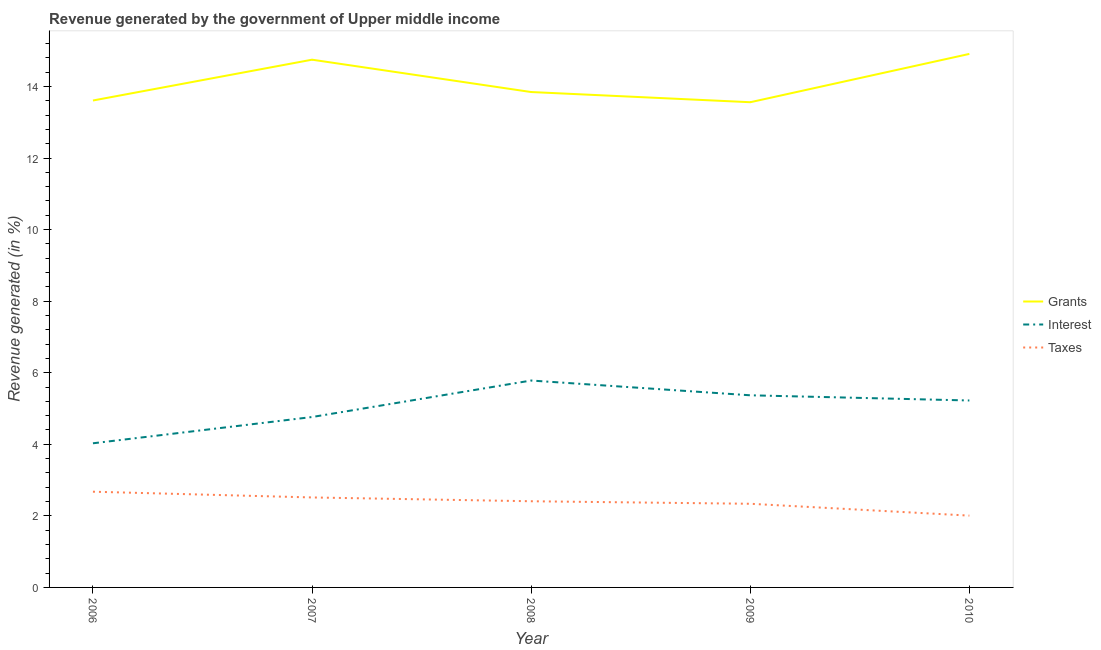Does the line corresponding to percentage of revenue generated by taxes intersect with the line corresponding to percentage of revenue generated by interest?
Provide a succinct answer. No. Is the number of lines equal to the number of legend labels?
Ensure brevity in your answer.  Yes. What is the percentage of revenue generated by taxes in 2010?
Give a very brief answer. 2.01. Across all years, what is the maximum percentage of revenue generated by taxes?
Give a very brief answer. 2.68. Across all years, what is the minimum percentage of revenue generated by interest?
Your answer should be compact. 4.03. In which year was the percentage of revenue generated by grants maximum?
Provide a succinct answer. 2010. In which year was the percentage of revenue generated by interest minimum?
Your response must be concise. 2006. What is the total percentage of revenue generated by taxes in the graph?
Your answer should be very brief. 11.94. What is the difference between the percentage of revenue generated by grants in 2006 and that in 2010?
Your answer should be compact. -1.3. What is the difference between the percentage of revenue generated by taxes in 2008 and the percentage of revenue generated by interest in 2006?
Keep it short and to the point. -1.62. What is the average percentage of revenue generated by grants per year?
Provide a short and direct response. 14.13. In the year 2007, what is the difference between the percentage of revenue generated by interest and percentage of revenue generated by taxes?
Make the answer very short. 2.25. In how many years, is the percentage of revenue generated by taxes greater than 14.4 %?
Keep it short and to the point. 0. What is the ratio of the percentage of revenue generated by grants in 2007 to that in 2009?
Your answer should be very brief. 1.09. Is the difference between the percentage of revenue generated by interest in 2006 and 2008 greater than the difference between the percentage of revenue generated by taxes in 2006 and 2008?
Keep it short and to the point. No. What is the difference between the highest and the second highest percentage of revenue generated by grants?
Make the answer very short. 0.16. What is the difference between the highest and the lowest percentage of revenue generated by interest?
Keep it short and to the point. 1.75. In how many years, is the percentage of revenue generated by interest greater than the average percentage of revenue generated by interest taken over all years?
Your response must be concise. 3. Is the sum of the percentage of revenue generated by taxes in 2006 and 2009 greater than the maximum percentage of revenue generated by interest across all years?
Provide a succinct answer. No. Is it the case that in every year, the sum of the percentage of revenue generated by grants and percentage of revenue generated by interest is greater than the percentage of revenue generated by taxes?
Ensure brevity in your answer.  Yes. Does the percentage of revenue generated by grants monotonically increase over the years?
Provide a succinct answer. No. Is the percentage of revenue generated by taxes strictly greater than the percentage of revenue generated by grants over the years?
Ensure brevity in your answer.  No. How many lines are there?
Your response must be concise. 3. How many years are there in the graph?
Keep it short and to the point. 5. What is the difference between two consecutive major ticks on the Y-axis?
Offer a very short reply. 2. Where does the legend appear in the graph?
Provide a short and direct response. Center right. How many legend labels are there?
Give a very brief answer. 3. What is the title of the graph?
Provide a short and direct response. Revenue generated by the government of Upper middle income. What is the label or title of the X-axis?
Ensure brevity in your answer.  Year. What is the label or title of the Y-axis?
Your answer should be very brief. Revenue generated (in %). What is the Revenue generated (in %) in Grants in 2006?
Provide a short and direct response. 13.61. What is the Revenue generated (in %) of Interest in 2006?
Offer a terse response. 4.03. What is the Revenue generated (in %) in Taxes in 2006?
Ensure brevity in your answer.  2.68. What is the Revenue generated (in %) of Grants in 2007?
Ensure brevity in your answer.  14.75. What is the Revenue generated (in %) of Interest in 2007?
Your response must be concise. 4.76. What is the Revenue generated (in %) in Taxes in 2007?
Provide a succinct answer. 2.51. What is the Revenue generated (in %) of Grants in 2008?
Keep it short and to the point. 13.84. What is the Revenue generated (in %) of Interest in 2008?
Ensure brevity in your answer.  5.78. What is the Revenue generated (in %) of Taxes in 2008?
Your answer should be compact. 2.41. What is the Revenue generated (in %) of Grants in 2009?
Your answer should be very brief. 13.56. What is the Revenue generated (in %) in Interest in 2009?
Ensure brevity in your answer.  5.37. What is the Revenue generated (in %) in Taxes in 2009?
Your answer should be very brief. 2.34. What is the Revenue generated (in %) of Grants in 2010?
Give a very brief answer. 14.91. What is the Revenue generated (in %) in Interest in 2010?
Your answer should be very brief. 5.22. What is the Revenue generated (in %) in Taxes in 2010?
Provide a short and direct response. 2.01. Across all years, what is the maximum Revenue generated (in %) in Grants?
Offer a terse response. 14.91. Across all years, what is the maximum Revenue generated (in %) in Interest?
Provide a succinct answer. 5.78. Across all years, what is the maximum Revenue generated (in %) of Taxes?
Provide a succinct answer. 2.68. Across all years, what is the minimum Revenue generated (in %) of Grants?
Give a very brief answer. 13.56. Across all years, what is the minimum Revenue generated (in %) in Interest?
Provide a short and direct response. 4.03. Across all years, what is the minimum Revenue generated (in %) of Taxes?
Provide a succinct answer. 2.01. What is the total Revenue generated (in %) in Grants in the graph?
Provide a short and direct response. 70.67. What is the total Revenue generated (in %) in Interest in the graph?
Your answer should be compact. 25.17. What is the total Revenue generated (in %) of Taxes in the graph?
Offer a terse response. 11.94. What is the difference between the Revenue generated (in %) of Grants in 2006 and that in 2007?
Make the answer very short. -1.14. What is the difference between the Revenue generated (in %) in Interest in 2006 and that in 2007?
Ensure brevity in your answer.  -0.73. What is the difference between the Revenue generated (in %) of Taxes in 2006 and that in 2007?
Provide a short and direct response. 0.16. What is the difference between the Revenue generated (in %) in Grants in 2006 and that in 2008?
Offer a terse response. -0.24. What is the difference between the Revenue generated (in %) of Interest in 2006 and that in 2008?
Ensure brevity in your answer.  -1.75. What is the difference between the Revenue generated (in %) of Taxes in 2006 and that in 2008?
Offer a terse response. 0.27. What is the difference between the Revenue generated (in %) of Grants in 2006 and that in 2009?
Your answer should be very brief. 0.05. What is the difference between the Revenue generated (in %) of Interest in 2006 and that in 2009?
Provide a short and direct response. -1.34. What is the difference between the Revenue generated (in %) of Taxes in 2006 and that in 2009?
Your answer should be compact. 0.34. What is the difference between the Revenue generated (in %) in Grants in 2006 and that in 2010?
Your answer should be very brief. -1.3. What is the difference between the Revenue generated (in %) of Interest in 2006 and that in 2010?
Your answer should be very brief. -1.2. What is the difference between the Revenue generated (in %) of Taxes in 2006 and that in 2010?
Make the answer very short. 0.67. What is the difference between the Revenue generated (in %) of Grants in 2007 and that in 2008?
Provide a succinct answer. 0.9. What is the difference between the Revenue generated (in %) in Interest in 2007 and that in 2008?
Offer a very short reply. -1.02. What is the difference between the Revenue generated (in %) in Taxes in 2007 and that in 2008?
Your answer should be compact. 0.11. What is the difference between the Revenue generated (in %) of Grants in 2007 and that in 2009?
Provide a succinct answer. 1.19. What is the difference between the Revenue generated (in %) of Interest in 2007 and that in 2009?
Keep it short and to the point. -0.61. What is the difference between the Revenue generated (in %) of Taxes in 2007 and that in 2009?
Make the answer very short. 0.18. What is the difference between the Revenue generated (in %) in Grants in 2007 and that in 2010?
Your answer should be very brief. -0.16. What is the difference between the Revenue generated (in %) of Interest in 2007 and that in 2010?
Give a very brief answer. -0.46. What is the difference between the Revenue generated (in %) in Taxes in 2007 and that in 2010?
Your response must be concise. 0.51. What is the difference between the Revenue generated (in %) of Grants in 2008 and that in 2009?
Give a very brief answer. 0.28. What is the difference between the Revenue generated (in %) in Interest in 2008 and that in 2009?
Give a very brief answer. 0.41. What is the difference between the Revenue generated (in %) of Taxes in 2008 and that in 2009?
Make the answer very short. 0.07. What is the difference between the Revenue generated (in %) of Grants in 2008 and that in 2010?
Your answer should be very brief. -1.07. What is the difference between the Revenue generated (in %) in Interest in 2008 and that in 2010?
Keep it short and to the point. 0.56. What is the difference between the Revenue generated (in %) in Taxes in 2008 and that in 2010?
Ensure brevity in your answer.  0.4. What is the difference between the Revenue generated (in %) of Grants in 2009 and that in 2010?
Offer a very short reply. -1.35. What is the difference between the Revenue generated (in %) of Interest in 2009 and that in 2010?
Keep it short and to the point. 0.14. What is the difference between the Revenue generated (in %) of Taxes in 2009 and that in 2010?
Your response must be concise. 0.33. What is the difference between the Revenue generated (in %) of Grants in 2006 and the Revenue generated (in %) of Interest in 2007?
Provide a short and direct response. 8.85. What is the difference between the Revenue generated (in %) in Grants in 2006 and the Revenue generated (in %) in Taxes in 2007?
Provide a short and direct response. 11.09. What is the difference between the Revenue generated (in %) of Interest in 2006 and the Revenue generated (in %) of Taxes in 2007?
Offer a very short reply. 1.51. What is the difference between the Revenue generated (in %) in Grants in 2006 and the Revenue generated (in %) in Interest in 2008?
Provide a short and direct response. 7.83. What is the difference between the Revenue generated (in %) in Grants in 2006 and the Revenue generated (in %) in Taxes in 2008?
Give a very brief answer. 11.2. What is the difference between the Revenue generated (in %) of Interest in 2006 and the Revenue generated (in %) of Taxes in 2008?
Your response must be concise. 1.62. What is the difference between the Revenue generated (in %) of Grants in 2006 and the Revenue generated (in %) of Interest in 2009?
Make the answer very short. 8.24. What is the difference between the Revenue generated (in %) of Grants in 2006 and the Revenue generated (in %) of Taxes in 2009?
Ensure brevity in your answer.  11.27. What is the difference between the Revenue generated (in %) of Interest in 2006 and the Revenue generated (in %) of Taxes in 2009?
Your response must be concise. 1.69. What is the difference between the Revenue generated (in %) in Grants in 2006 and the Revenue generated (in %) in Interest in 2010?
Provide a short and direct response. 8.38. What is the difference between the Revenue generated (in %) in Grants in 2006 and the Revenue generated (in %) in Taxes in 2010?
Keep it short and to the point. 11.6. What is the difference between the Revenue generated (in %) in Interest in 2006 and the Revenue generated (in %) in Taxes in 2010?
Give a very brief answer. 2.02. What is the difference between the Revenue generated (in %) in Grants in 2007 and the Revenue generated (in %) in Interest in 2008?
Offer a very short reply. 8.97. What is the difference between the Revenue generated (in %) in Grants in 2007 and the Revenue generated (in %) in Taxes in 2008?
Offer a terse response. 12.34. What is the difference between the Revenue generated (in %) of Interest in 2007 and the Revenue generated (in %) of Taxes in 2008?
Offer a very short reply. 2.35. What is the difference between the Revenue generated (in %) of Grants in 2007 and the Revenue generated (in %) of Interest in 2009?
Your answer should be very brief. 9.38. What is the difference between the Revenue generated (in %) of Grants in 2007 and the Revenue generated (in %) of Taxes in 2009?
Give a very brief answer. 12.41. What is the difference between the Revenue generated (in %) in Interest in 2007 and the Revenue generated (in %) in Taxes in 2009?
Give a very brief answer. 2.42. What is the difference between the Revenue generated (in %) in Grants in 2007 and the Revenue generated (in %) in Interest in 2010?
Ensure brevity in your answer.  9.52. What is the difference between the Revenue generated (in %) in Grants in 2007 and the Revenue generated (in %) in Taxes in 2010?
Offer a terse response. 12.74. What is the difference between the Revenue generated (in %) of Interest in 2007 and the Revenue generated (in %) of Taxes in 2010?
Offer a very short reply. 2.76. What is the difference between the Revenue generated (in %) in Grants in 2008 and the Revenue generated (in %) in Interest in 2009?
Your answer should be very brief. 8.48. What is the difference between the Revenue generated (in %) of Grants in 2008 and the Revenue generated (in %) of Taxes in 2009?
Provide a succinct answer. 11.51. What is the difference between the Revenue generated (in %) of Interest in 2008 and the Revenue generated (in %) of Taxes in 2009?
Ensure brevity in your answer.  3.44. What is the difference between the Revenue generated (in %) in Grants in 2008 and the Revenue generated (in %) in Interest in 2010?
Give a very brief answer. 8.62. What is the difference between the Revenue generated (in %) of Grants in 2008 and the Revenue generated (in %) of Taxes in 2010?
Your answer should be compact. 11.84. What is the difference between the Revenue generated (in %) of Interest in 2008 and the Revenue generated (in %) of Taxes in 2010?
Keep it short and to the point. 3.78. What is the difference between the Revenue generated (in %) in Grants in 2009 and the Revenue generated (in %) in Interest in 2010?
Ensure brevity in your answer.  8.34. What is the difference between the Revenue generated (in %) in Grants in 2009 and the Revenue generated (in %) in Taxes in 2010?
Your response must be concise. 11.55. What is the difference between the Revenue generated (in %) in Interest in 2009 and the Revenue generated (in %) in Taxes in 2010?
Offer a very short reply. 3.36. What is the average Revenue generated (in %) in Grants per year?
Your response must be concise. 14.13. What is the average Revenue generated (in %) in Interest per year?
Your answer should be very brief. 5.03. What is the average Revenue generated (in %) in Taxes per year?
Provide a succinct answer. 2.39. In the year 2006, what is the difference between the Revenue generated (in %) of Grants and Revenue generated (in %) of Interest?
Offer a very short reply. 9.58. In the year 2006, what is the difference between the Revenue generated (in %) in Grants and Revenue generated (in %) in Taxes?
Make the answer very short. 10.93. In the year 2006, what is the difference between the Revenue generated (in %) of Interest and Revenue generated (in %) of Taxes?
Make the answer very short. 1.35. In the year 2007, what is the difference between the Revenue generated (in %) in Grants and Revenue generated (in %) in Interest?
Provide a short and direct response. 9.99. In the year 2007, what is the difference between the Revenue generated (in %) of Grants and Revenue generated (in %) of Taxes?
Keep it short and to the point. 12.23. In the year 2007, what is the difference between the Revenue generated (in %) in Interest and Revenue generated (in %) in Taxes?
Your answer should be compact. 2.25. In the year 2008, what is the difference between the Revenue generated (in %) in Grants and Revenue generated (in %) in Interest?
Your answer should be very brief. 8.06. In the year 2008, what is the difference between the Revenue generated (in %) in Grants and Revenue generated (in %) in Taxes?
Keep it short and to the point. 11.44. In the year 2008, what is the difference between the Revenue generated (in %) in Interest and Revenue generated (in %) in Taxes?
Offer a terse response. 3.37. In the year 2009, what is the difference between the Revenue generated (in %) in Grants and Revenue generated (in %) in Interest?
Offer a terse response. 8.19. In the year 2009, what is the difference between the Revenue generated (in %) of Grants and Revenue generated (in %) of Taxes?
Make the answer very short. 11.22. In the year 2009, what is the difference between the Revenue generated (in %) in Interest and Revenue generated (in %) in Taxes?
Your answer should be very brief. 3.03. In the year 2010, what is the difference between the Revenue generated (in %) in Grants and Revenue generated (in %) in Interest?
Keep it short and to the point. 9.69. In the year 2010, what is the difference between the Revenue generated (in %) in Grants and Revenue generated (in %) in Taxes?
Ensure brevity in your answer.  12.9. In the year 2010, what is the difference between the Revenue generated (in %) in Interest and Revenue generated (in %) in Taxes?
Your answer should be very brief. 3.22. What is the ratio of the Revenue generated (in %) in Grants in 2006 to that in 2007?
Give a very brief answer. 0.92. What is the ratio of the Revenue generated (in %) in Interest in 2006 to that in 2007?
Keep it short and to the point. 0.85. What is the ratio of the Revenue generated (in %) of Taxes in 2006 to that in 2007?
Provide a short and direct response. 1.06. What is the ratio of the Revenue generated (in %) in Grants in 2006 to that in 2008?
Your response must be concise. 0.98. What is the ratio of the Revenue generated (in %) in Interest in 2006 to that in 2008?
Your answer should be very brief. 0.7. What is the ratio of the Revenue generated (in %) in Taxes in 2006 to that in 2008?
Provide a short and direct response. 1.11. What is the ratio of the Revenue generated (in %) of Grants in 2006 to that in 2009?
Provide a short and direct response. 1. What is the ratio of the Revenue generated (in %) of Interest in 2006 to that in 2009?
Offer a very short reply. 0.75. What is the ratio of the Revenue generated (in %) of Taxes in 2006 to that in 2009?
Your response must be concise. 1.14. What is the ratio of the Revenue generated (in %) of Grants in 2006 to that in 2010?
Your response must be concise. 0.91. What is the ratio of the Revenue generated (in %) in Interest in 2006 to that in 2010?
Ensure brevity in your answer.  0.77. What is the ratio of the Revenue generated (in %) of Taxes in 2006 to that in 2010?
Give a very brief answer. 1.33. What is the ratio of the Revenue generated (in %) in Grants in 2007 to that in 2008?
Make the answer very short. 1.07. What is the ratio of the Revenue generated (in %) in Interest in 2007 to that in 2008?
Provide a succinct answer. 0.82. What is the ratio of the Revenue generated (in %) in Taxes in 2007 to that in 2008?
Your answer should be compact. 1.04. What is the ratio of the Revenue generated (in %) in Grants in 2007 to that in 2009?
Provide a short and direct response. 1.09. What is the ratio of the Revenue generated (in %) in Interest in 2007 to that in 2009?
Your answer should be compact. 0.89. What is the ratio of the Revenue generated (in %) of Taxes in 2007 to that in 2009?
Offer a very short reply. 1.08. What is the ratio of the Revenue generated (in %) in Interest in 2007 to that in 2010?
Offer a terse response. 0.91. What is the ratio of the Revenue generated (in %) of Taxes in 2007 to that in 2010?
Your response must be concise. 1.25. What is the ratio of the Revenue generated (in %) of Grants in 2008 to that in 2009?
Offer a terse response. 1.02. What is the ratio of the Revenue generated (in %) in Interest in 2008 to that in 2009?
Ensure brevity in your answer.  1.08. What is the ratio of the Revenue generated (in %) of Taxes in 2008 to that in 2009?
Make the answer very short. 1.03. What is the ratio of the Revenue generated (in %) of Grants in 2008 to that in 2010?
Your answer should be compact. 0.93. What is the ratio of the Revenue generated (in %) in Interest in 2008 to that in 2010?
Your answer should be very brief. 1.11. What is the ratio of the Revenue generated (in %) of Taxes in 2008 to that in 2010?
Your answer should be compact. 1.2. What is the ratio of the Revenue generated (in %) of Grants in 2009 to that in 2010?
Your answer should be compact. 0.91. What is the ratio of the Revenue generated (in %) in Interest in 2009 to that in 2010?
Your answer should be compact. 1.03. What is the ratio of the Revenue generated (in %) in Taxes in 2009 to that in 2010?
Give a very brief answer. 1.17. What is the difference between the highest and the second highest Revenue generated (in %) in Grants?
Keep it short and to the point. 0.16. What is the difference between the highest and the second highest Revenue generated (in %) of Interest?
Keep it short and to the point. 0.41. What is the difference between the highest and the second highest Revenue generated (in %) of Taxes?
Your answer should be compact. 0.16. What is the difference between the highest and the lowest Revenue generated (in %) of Grants?
Make the answer very short. 1.35. What is the difference between the highest and the lowest Revenue generated (in %) in Interest?
Keep it short and to the point. 1.75. What is the difference between the highest and the lowest Revenue generated (in %) in Taxes?
Your answer should be compact. 0.67. 